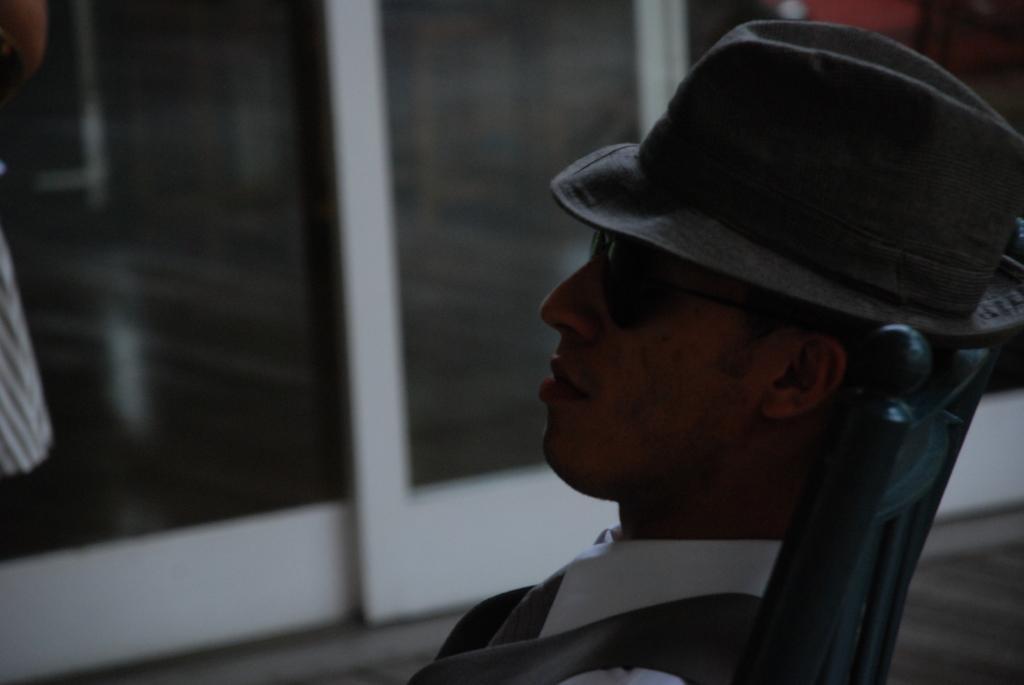Describe this image in one or two sentences. In this picture, we see a man in a white shirt who is wearing a hat and goggles is sitting on the black chair. Beside him, there is a black door. In the background, it is blurred and this picture might be clicked in the dark. 